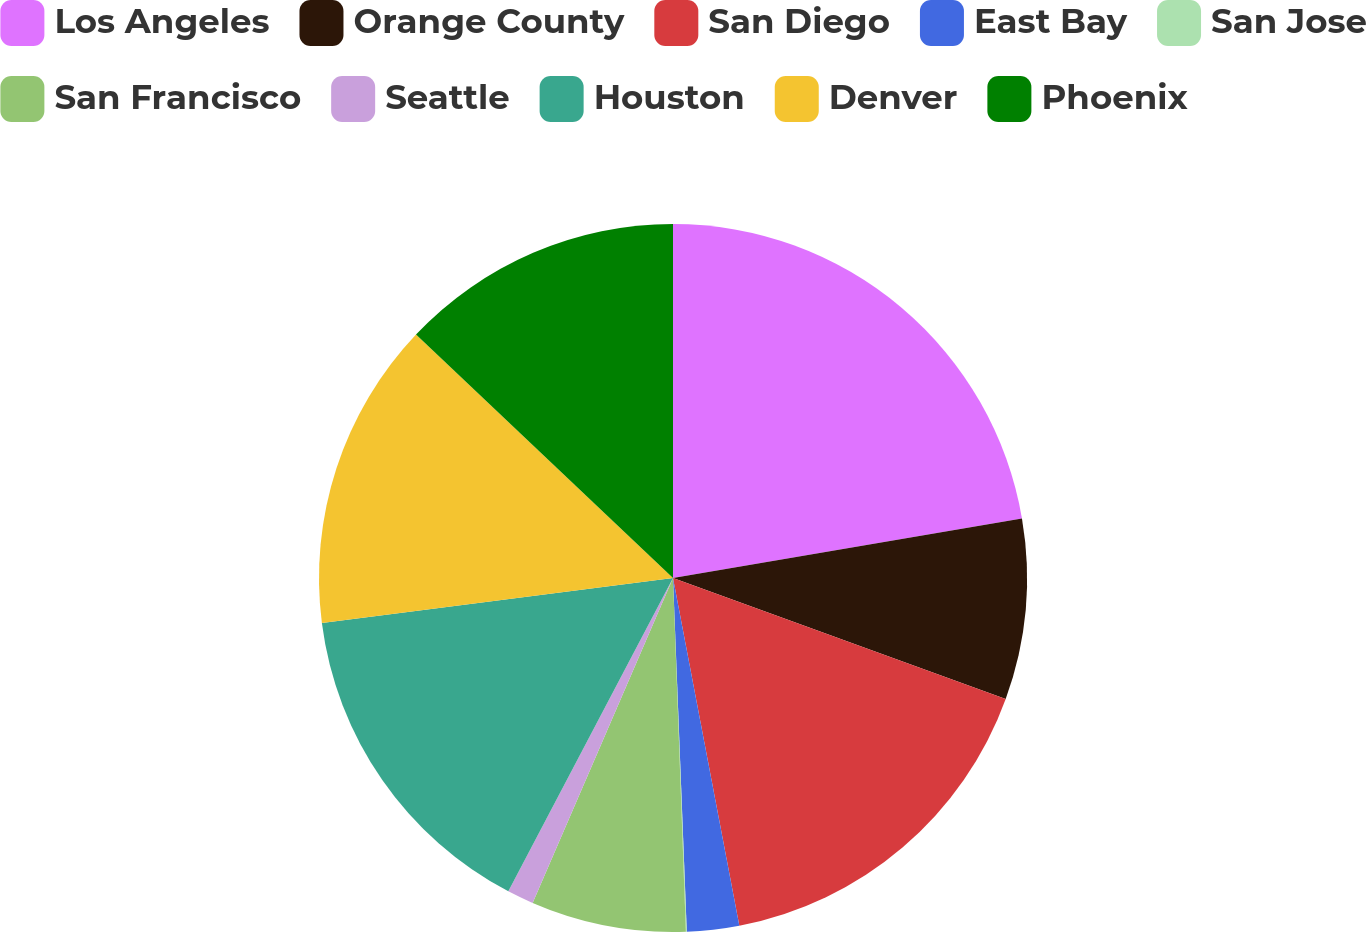Convert chart to OTSL. <chart><loc_0><loc_0><loc_500><loc_500><pie_chart><fcel>Los Angeles<fcel>Orange County<fcel>San Diego<fcel>East Bay<fcel>San Jose<fcel>San Francisco<fcel>Seattle<fcel>Houston<fcel>Denver<fcel>Phoenix<nl><fcel>22.31%<fcel>8.24%<fcel>16.45%<fcel>2.38%<fcel>0.04%<fcel>7.07%<fcel>1.21%<fcel>15.27%<fcel>14.1%<fcel>12.93%<nl></chart> 